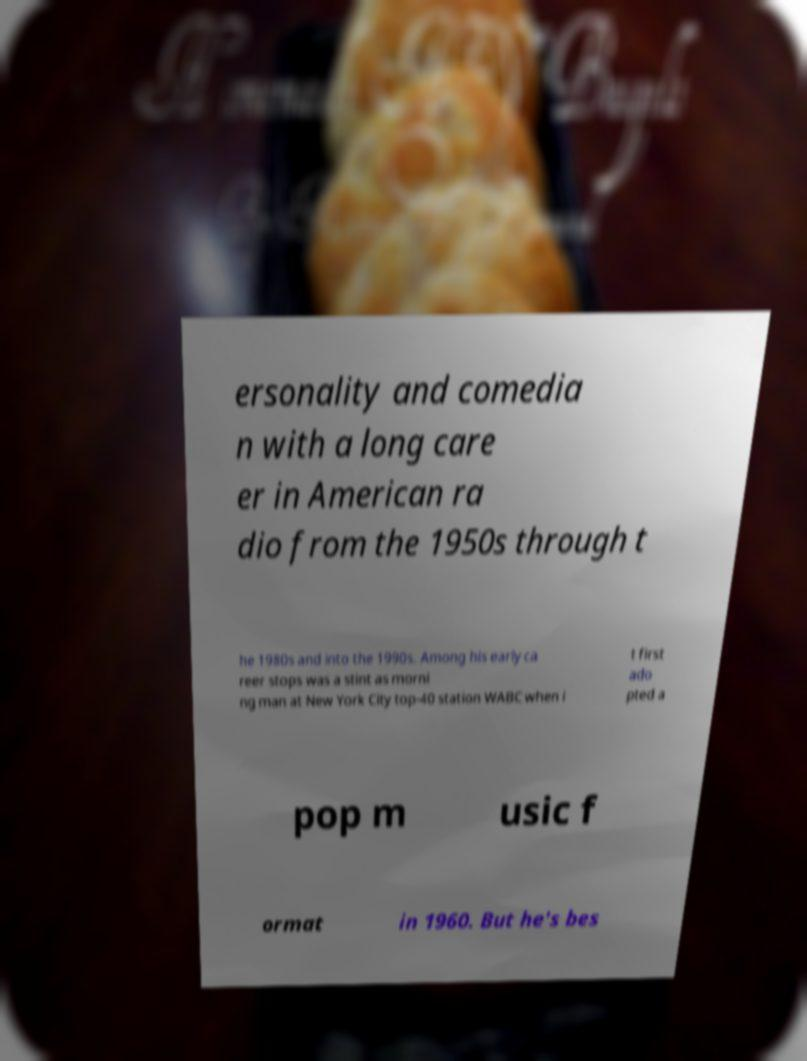Can you read and provide the text displayed in the image?This photo seems to have some interesting text. Can you extract and type it out for me? ersonality and comedia n with a long care er in American ra dio from the 1950s through t he 1980s and into the 1990s. Among his early ca reer stops was a stint as morni ng man at New York City top-40 station WABC when i t first ado pted a pop m usic f ormat in 1960. But he's bes 